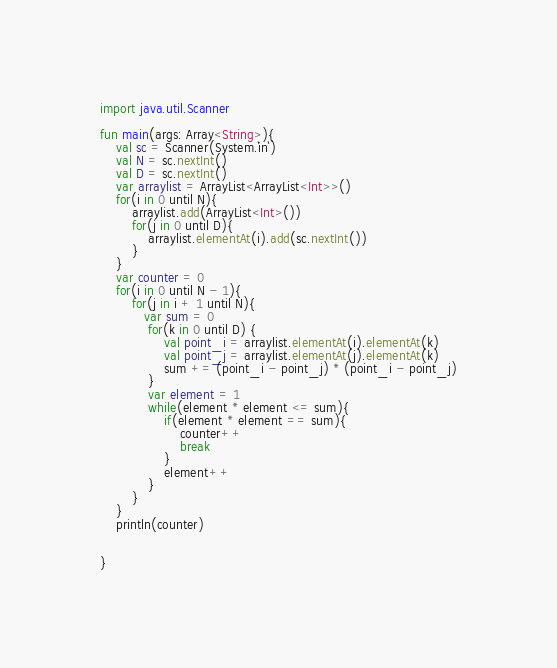Convert code to text. <code><loc_0><loc_0><loc_500><loc_500><_Kotlin_>import java.util.Scanner

fun main(args: Array<String>){
    val sc = Scanner(System.`in`)
    val N = sc.nextInt()
    val D = sc.nextInt()
    var arraylist = ArrayList<ArrayList<Int>>()
    for(i in 0 until N){
        arraylist.add(ArrayList<Int>())
        for(j in 0 until D){
            arraylist.elementAt(i).add(sc.nextInt())
        }
    }
    var counter = 0
    for(i in 0 until N - 1){
        for(j in i + 1 until N){
           var sum = 0
            for(k in 0 until D) {
                val point_i = arraylist.elementAt(i).elementAt(k)
                val point_j = arraylist.elementAt(j).elementAt(k)
                sum += (point_i - point_j) * (point_i - point_j)
            }
            var element = 1
            while(element * element <= sum){
                if(element * element == sum){
                    counter++
                    break
                }
                element++
            }
        }
    }
    println(counter)


}</code> 